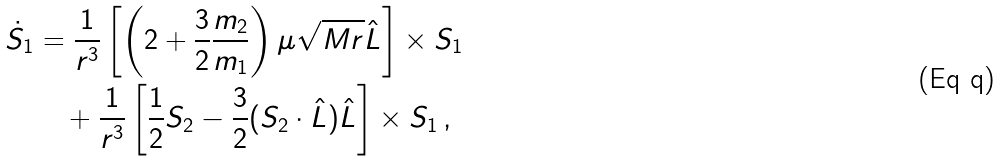Convert formula to latex. <formula><loc_0><loc_0><loc_500><loc_500>\dot { S } _ { 1 } & = \frac { 1 } { r ^ { 3 } } \left [ \left ( 2 + \frac { 3 } { 2 } \frac { m _ { 2 } } { m _ { 1 } } \right ) \mu \sqrt { M r } \hat { L } \right ] \times S _ { 1 } \\ & \quad + \frac { 1 } { r ^ { 3 } } \left [ \frac { 1 } { 2 } S _ { 2 } - \frac { 3 } { 2 } ( S _ { 2 } \cdot \hat { L } ) \hat { L } \right ] \times S _ { 1 } \, ,</formula> 